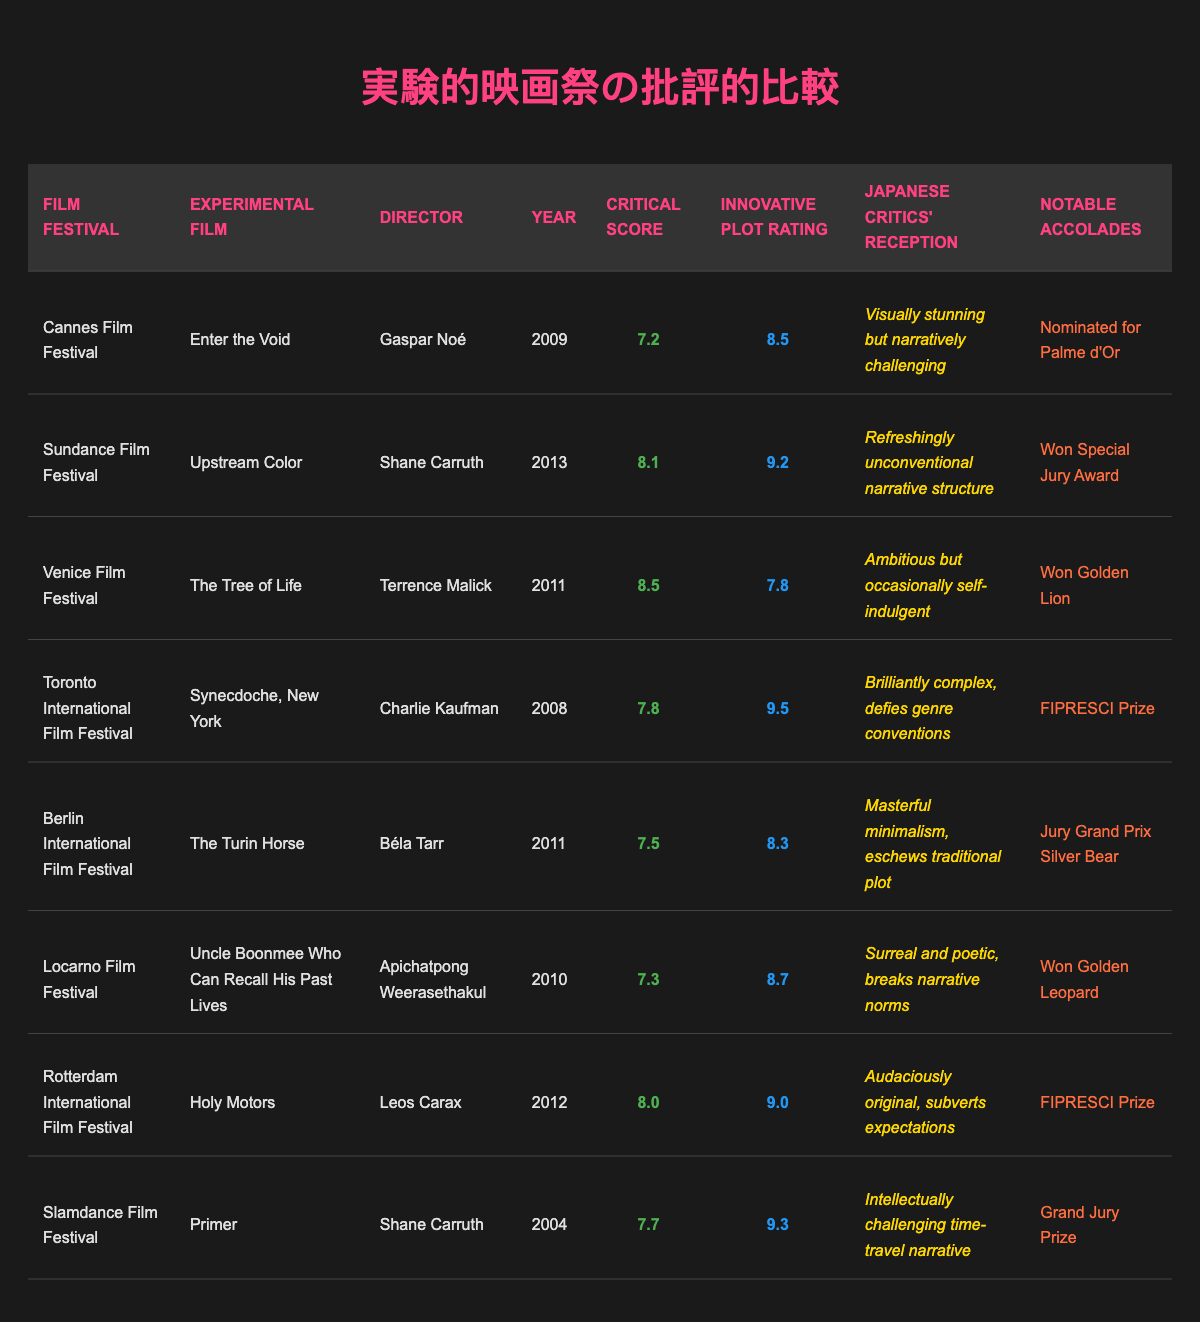What is the highest critical score among the experimental films listed? The critical scores are: 7.2, 8.1, 8.5, 7.8, 7.5, 7.3, 8.0, and 7.7. The highest value among these is 8.5.
Answer: 8.5 Which director has the film with the lowest critical score, and what is that score? The critical scores are compared: the lowest is 7.2 for "Enter the Void" by Gaspar Noé.
Answer: Gaspar Noé, 7.2 What is the average innovative plot rating of all the experimental films listed? The innovative ratings are 8.5, 9.2, 7.8, 9.5, 8.3, 8.7, 9.0, and 9.3. Adding these gives 70.3 and dividing by 8 (the number of films) yields 8.7875, which rounds to 8.8.
Answer: 8.8 Did any film win an accolade at a film festival? The films with accolades include those that won the Golden Lion, FIPRESCI Prize, Grand Jury Prize, and the Golden Leopard. Thus, yes, multiple films won accolades.
Answer: Yes Which film had the most favorable Japanese critics' reception? The Japanese critics' reception statements need to be compared. "Upstream Color" is described as refreshingly unconventional, while all others have more neutral or critical remarks.
Answer: Upstream Color What is the difference between the highest and lowest innovative plot ratings? The highest innovative plot rating is 9.5 (for "Synecdoche, New York") and the lowest is 7.8 (for "The Tree of Life"). The difference is 9.5 - 7.8 = 1.7.
Answer: 1.7 How many films directed by Shane Carruth are listed, and what are their titles? Two films are directed by Shane Carruth, which are "Primer" (2004) and "Upstream Color" (2013).
Answer: Two; Primer, Upstream Color Which film was screened at the Toronto International Film Festival, and what was its critical score? "Synecdoche, New York" was screened at the Toronto International Film Festival, receiving a critical score of 7.8.
Answer: Synecdoche, New York, 7.8 